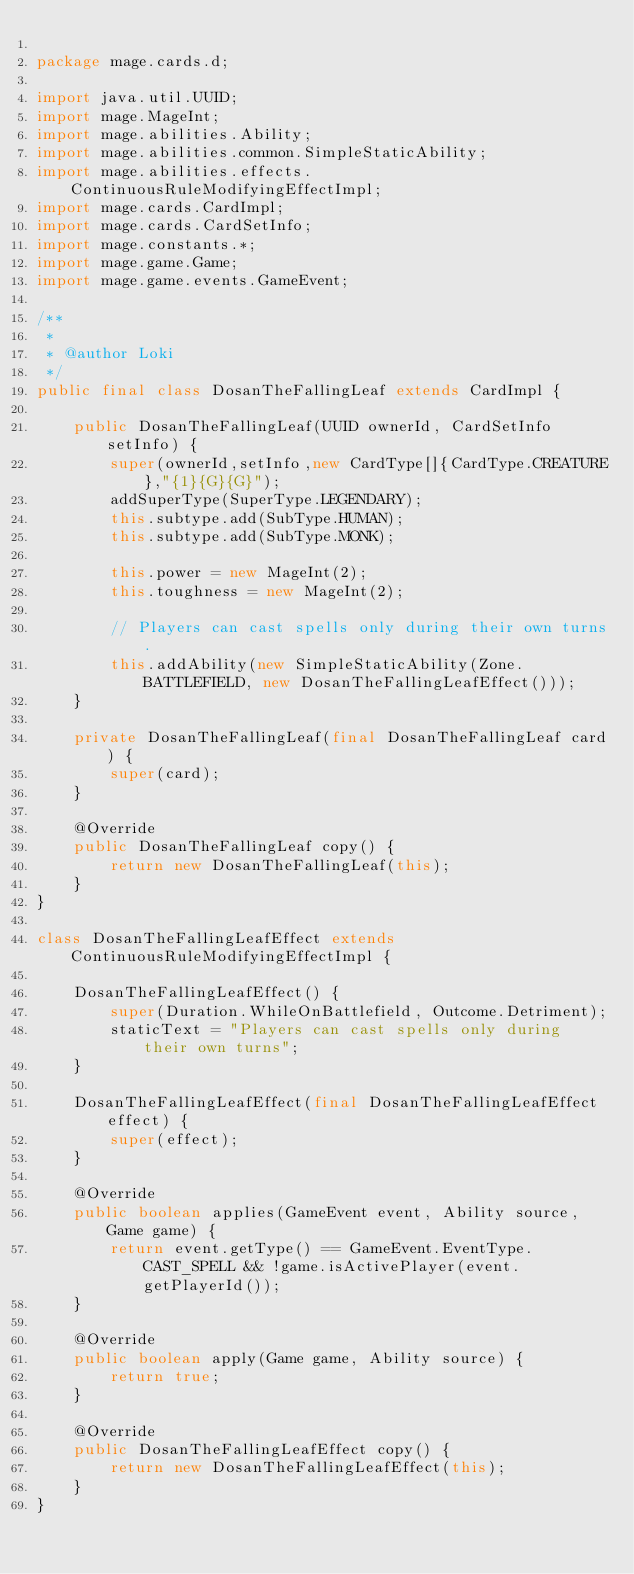<code> <loc_0><loc_0><loc_500><loc_500><_Java_>
package mage.cards.d;

import java.util.UUID;
import mage.MageInt;
import mage.abilities.Ability;
import mage.abilities.common.SimpleStaticAbility;
import mage.abilities.effects.ContinuousRuleModifyingEffectImpl;
import mage.cards.CardImpl;
import mage.cards.CardSetInfo;
import mage.constants.*;
import mage.game.Game;
import mage.game.events.GameEvent;

/**
 *
 * @author Loki
 */
public final class DosanTheFallingLeaf extends CardImpl {

    public DosanTheFallingLeaf(UUID ownerId, CardSetInfo setInfo) {
        super(ownerId,setInfo,new CardType[]{CardType.CREATURE},"{1}{G}{G}");
        addSuperType(SuperType.LEGENDARY);
        this.subtype.add(SubType.HUMAN);
        this.subtype.add(SubType.MONK);

        this.power = new MageInt(2);
        this.toughness = new MageInt(2);

        // Players can cast spells only during their own turns.
        this.addAbility(new SimpleStaticAbility(Zone.BATTLEFIELD, new DosanTheFallingLeafEffect()));
    }

    private DosanTheFallingLeaf(final DosanTheFallingLeaf card) {
        super(card);
    }

    @Override
    public DosanTheFallingLeaf copy() {
        return new DosanTheFallingLeaf(this);
    }
}

class DosanTheFallingLeafEffect extends ContinuousRuleModifyingEffectImpl {

    DosanTheFallingLeafEffect() {
        super(Duration.WhileOnBattlefield, Outcome.Detriment);
        staticText = "Players can cast spells only during their own turns";
    }

    DosanTheFallingLeafEffect(final DosanTheFallingLeafEffect effect) {
        super(effect);
    }

    @Override
    public boolean applies(GameEvent event, Ability source, Game game) {
        return event.getType() == GameEvent.EventType.CAST_SPELL && !game.isActivePlayer(event.getPlayerId());
    }

    @Override
    public boolean apply(Game game, Ability source) {
        return true;
    }

    @Override
    public DosanTheFallingLeafEffect copy() {
        return new DosanTheFallingLeafEffect(this);
    }
}
</code> 